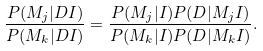Convert formula to latex. <formula><loc_0><loc_0><loc_500><loc_500>\frac { P ( M _ { j } | D I ) } { P ( M _ { k } | D I ) } = \frac { P ( M _ { j } | I ) P ( D | M _ { j } I ) } { P ( M _ { k } | I ) P ( D | M _ { k } I ) } .</formula> 